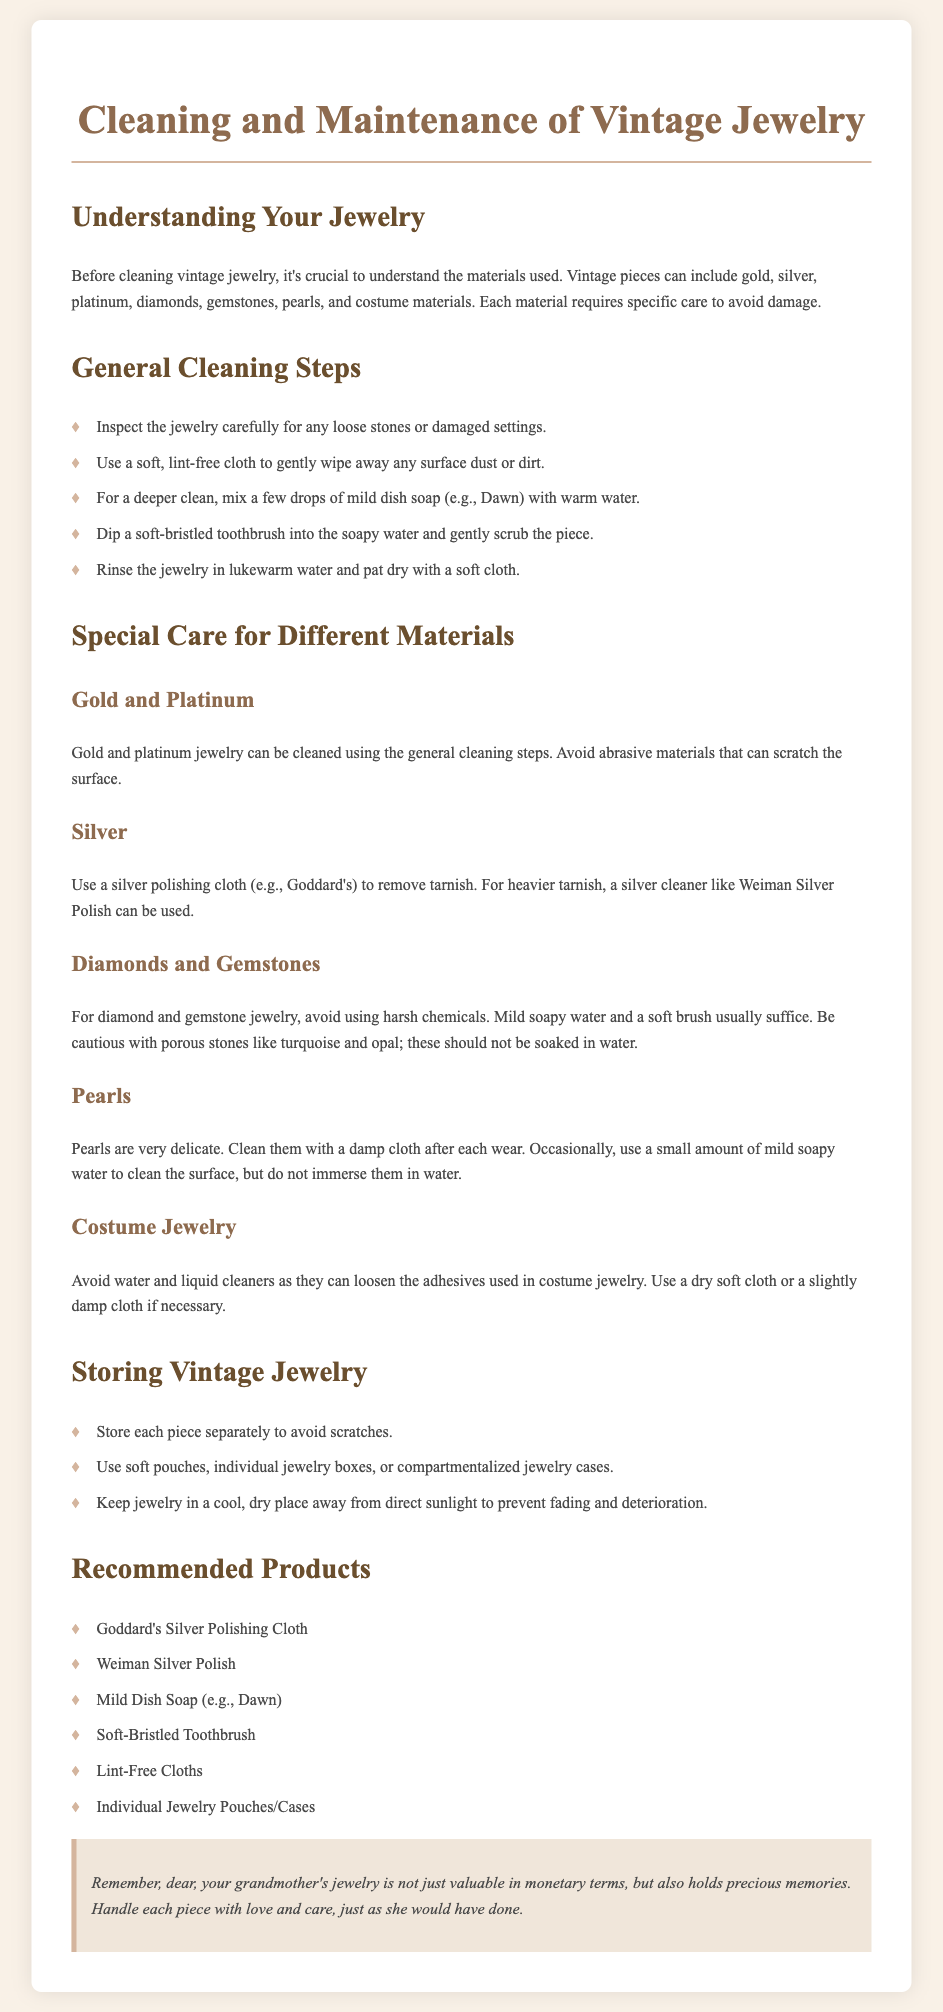what should you use to clean silver jewelry? The document recommends using a silver polishing cloth or a specific silver cleaner for tarnish removal.
Answer: silver polishing cloth what is the first step in general cleaning? The first step involves inspecting the jewelry carefully for any loose stones or damaged settings.
Answer: Inspect the jewelry how should you clean pearls? Pearls should be cleaned with a damp cloth after each wear and a small amount of soapy water occasionally.
Answer: damp cloth what type of soap is recommended for cleaning vintage jewelry? A mild dish soap, such as Dawn, is recommended for cleaning vintage jewelry.
Answer: mild dish soap how should costume jewelry be cleaned? Costume jewelry should be cleaned using a dry soft cloth or a slightly damp cloth.
Answer: dry soft cloth what is a key storage tip for vintage jewelry? A key storage tip includes storing each piece separately to avoid scratches.
Answer: store separately which product is suggested for silver polishing? Goddard's Silver Polishing Cloth is suggested for silver polishing.
Answer: Goddard's Silver Polishing Cloth what should be avoided when cleaning porous stones? Soaking porous stones like turquoise and opal should be avoided when cleaning.
Answer: soaking what is the recommended storage condition for vintage jewelry? Jewelry should be kept in a cool, dry place away from direct sunlight.
Answer: cool, dry place 